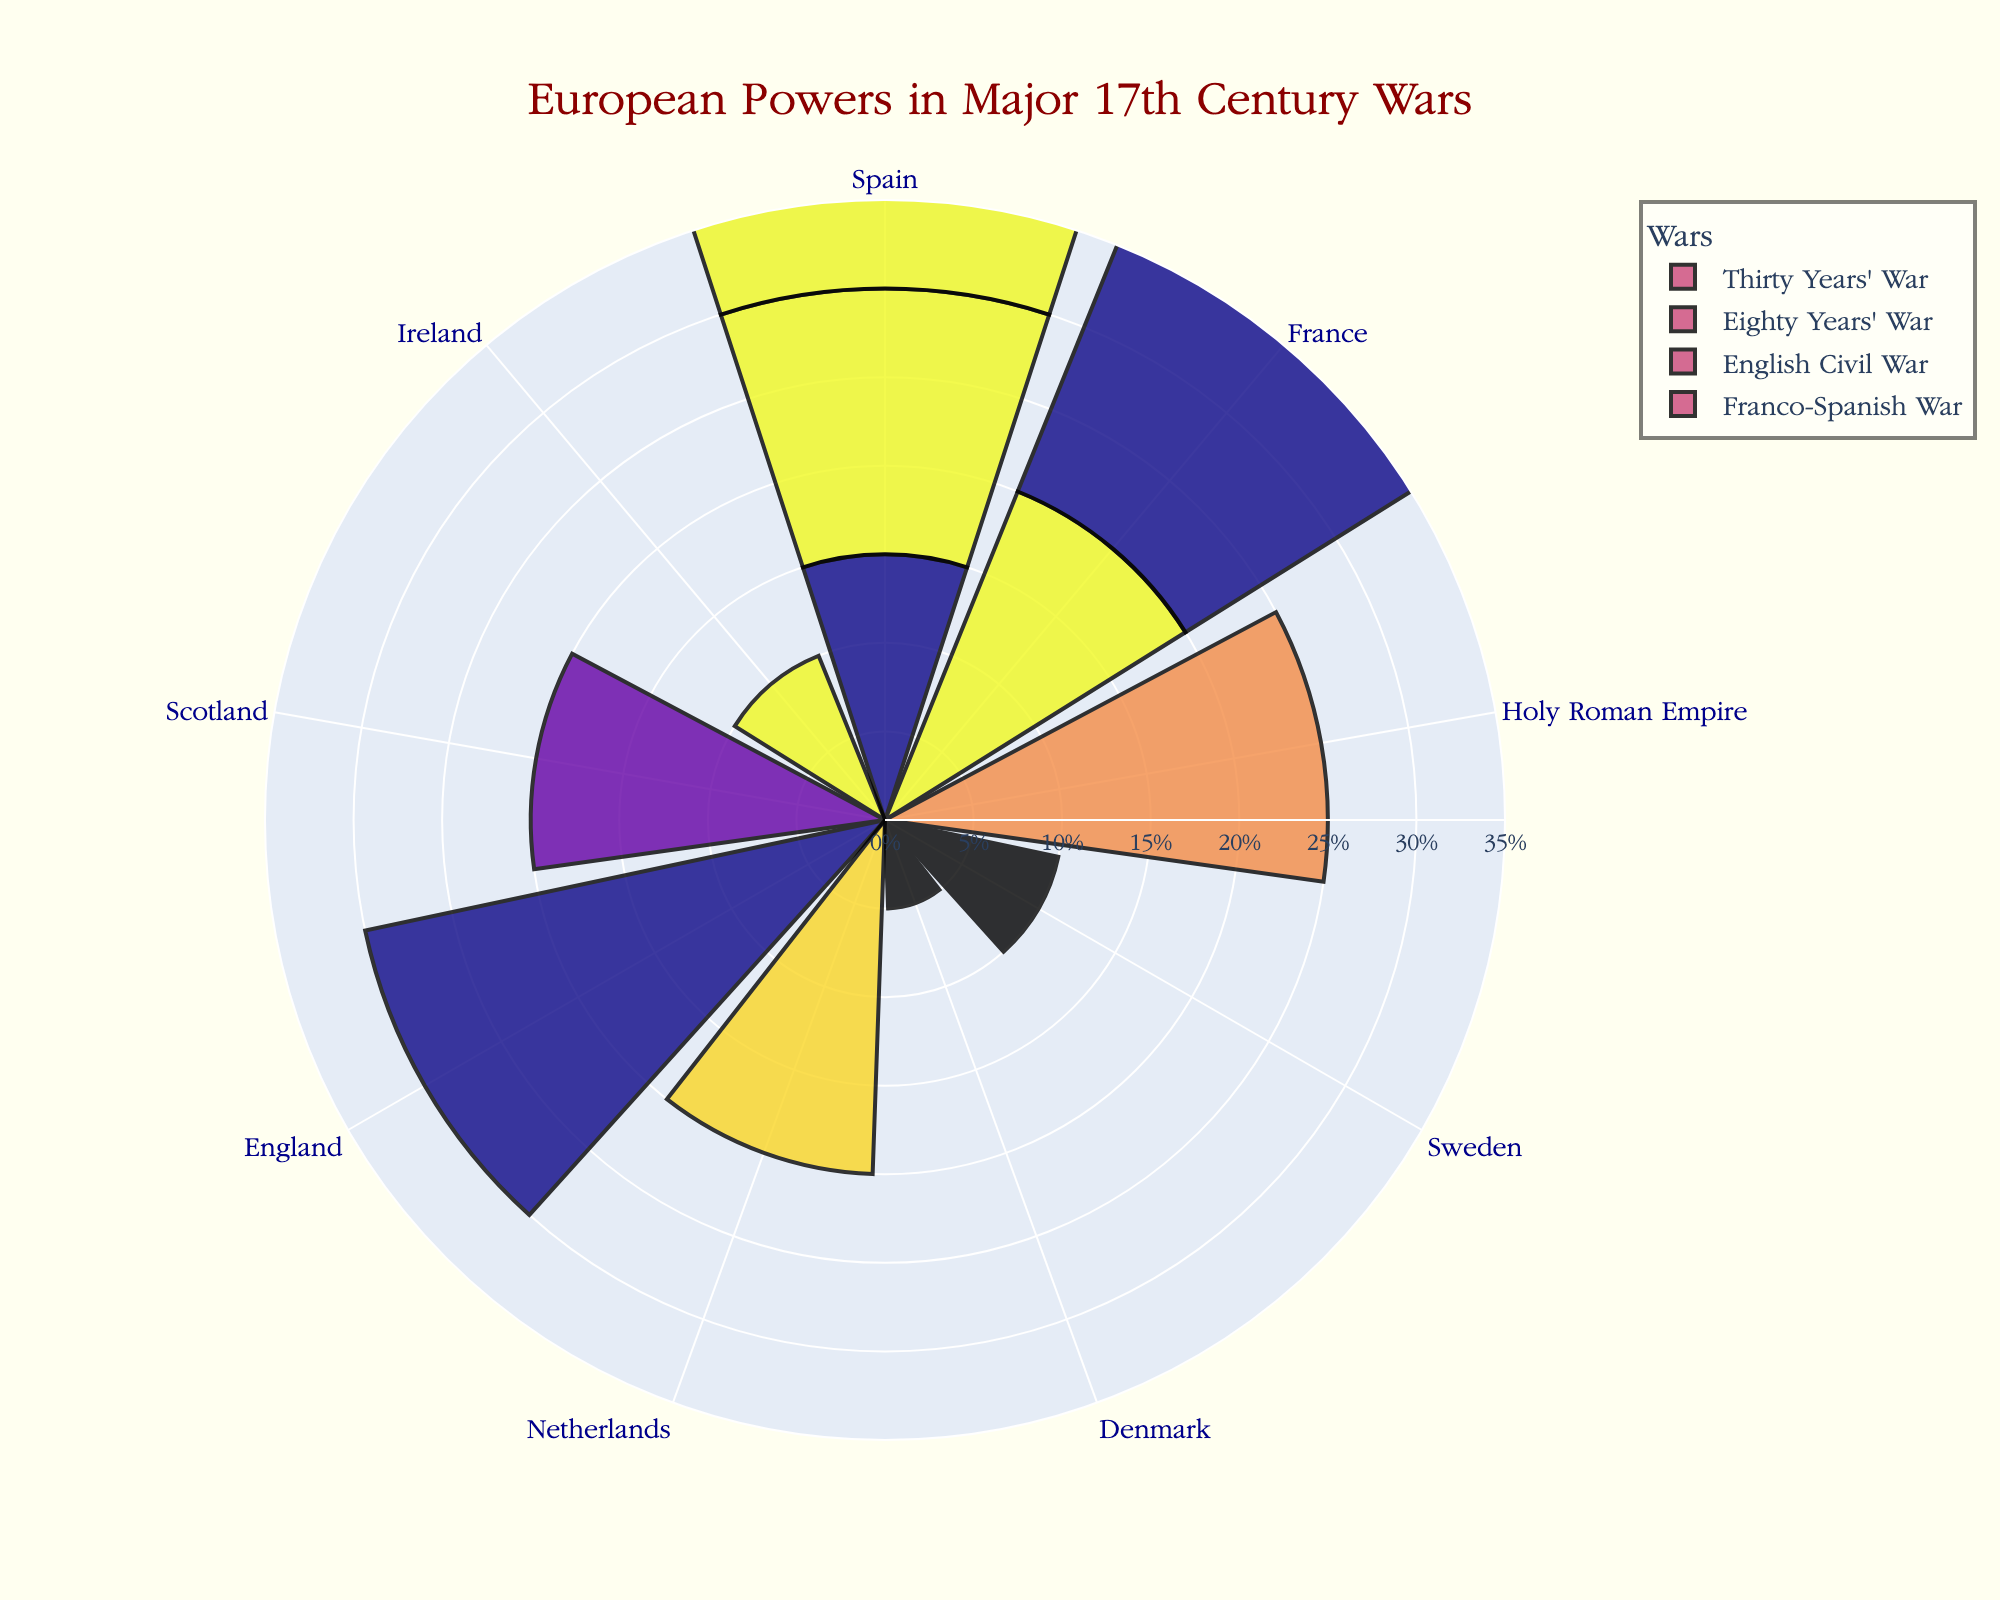What's the title of the chart? The title is located at the top of the chart and is written in a larger font size. It's designed to give a clear understanding of what the chart represents.
Answer: "European Powers in Major 17th Century Wars" Which country has the highest proportion in the English Civil War? Look at the sector labeled 'English Civil War' and identify the country with the largest proportion within that section.
Answer: England How many wars are represented in the chart? Count the unique labels or sections representing different wars around the chart.
Answer: 4 Which two countries share an equal proportion in the Franco-Spanish War? Inspect the section labeled 'Franco-Spanish War' and identify the countries with bars of equal length.
Answer: France and Spain What's the total proportion represented by the Holy Roman Empire? The Holy Roman Empire is involved in only one war (Thirty Years' War). Look for its section and add up the proportions listed.
Answer: 0.25 Compare the proportions of Spain in the Thirty Years' War and the Franco-Spanish War. Which one is larger? Find the sections for the Thirty Years' War and Franco-Spanish War, identify Spain’s proportions in both, and compare them.
Answer: Proportion in Franco-Spanish War is larger Which war features the most countries involved? Count the number of distinct countries in each war section and identify the one with the highest count.
Answer: Thirty Years' War How much proportion does Denmark contribute in the Thirty Years' War compared to Sweden? Examine the Thirty Years' War section and compare the proportions for Denmark and Sweden.
Answer: Sweden has a larger proportion What's the combined proportion of countries involved in both the Eighty Years' War and the English Civil War? Add the proportions of all countries in the Eighty Years' War and the English Civil War sections.
Answer: 0.95 